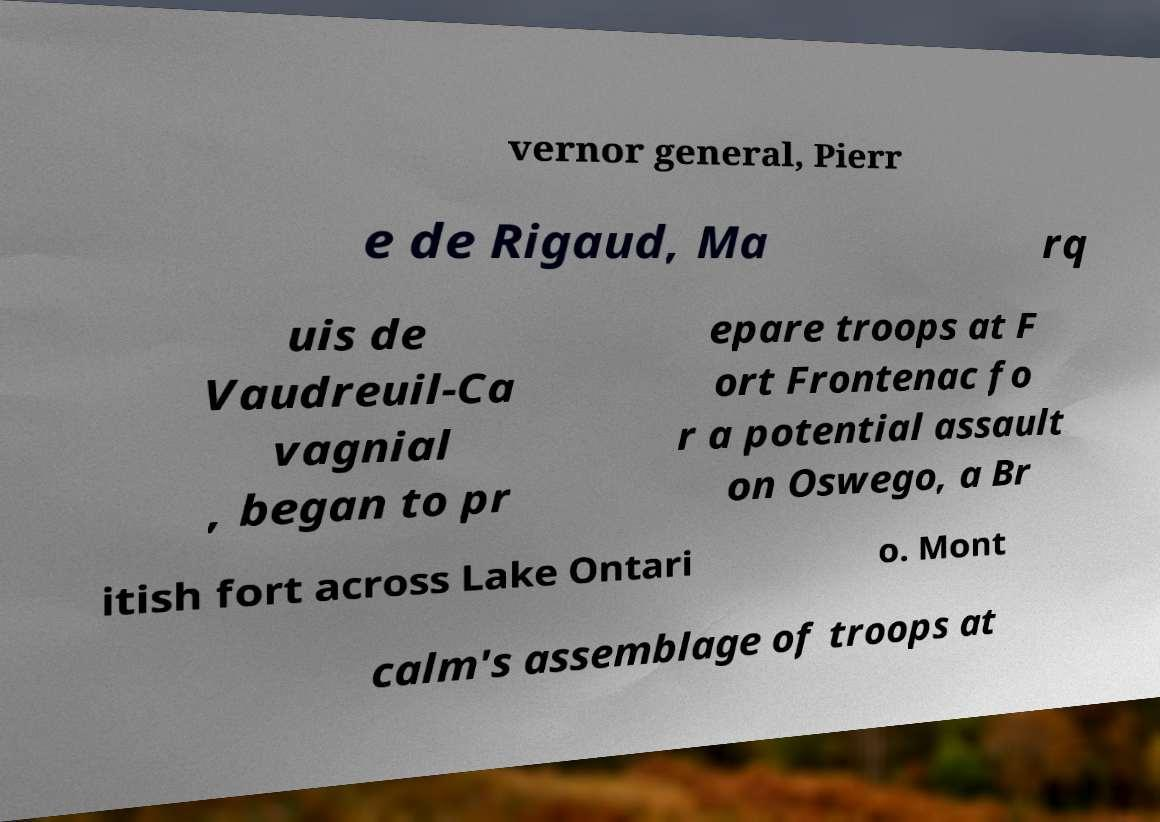For documentation purposes, I need the text within this image transcribed. Could you provide that? vernor general, Pierr e de Rigaud, Ma rq uis de Vaudreuil-Ca vagnial , began to pr epare troops at F ort Frontenac fo r a potential assault on Oswego, a Br itish fort across Lake Ontari o. Mont calm's assemblage of troops at 